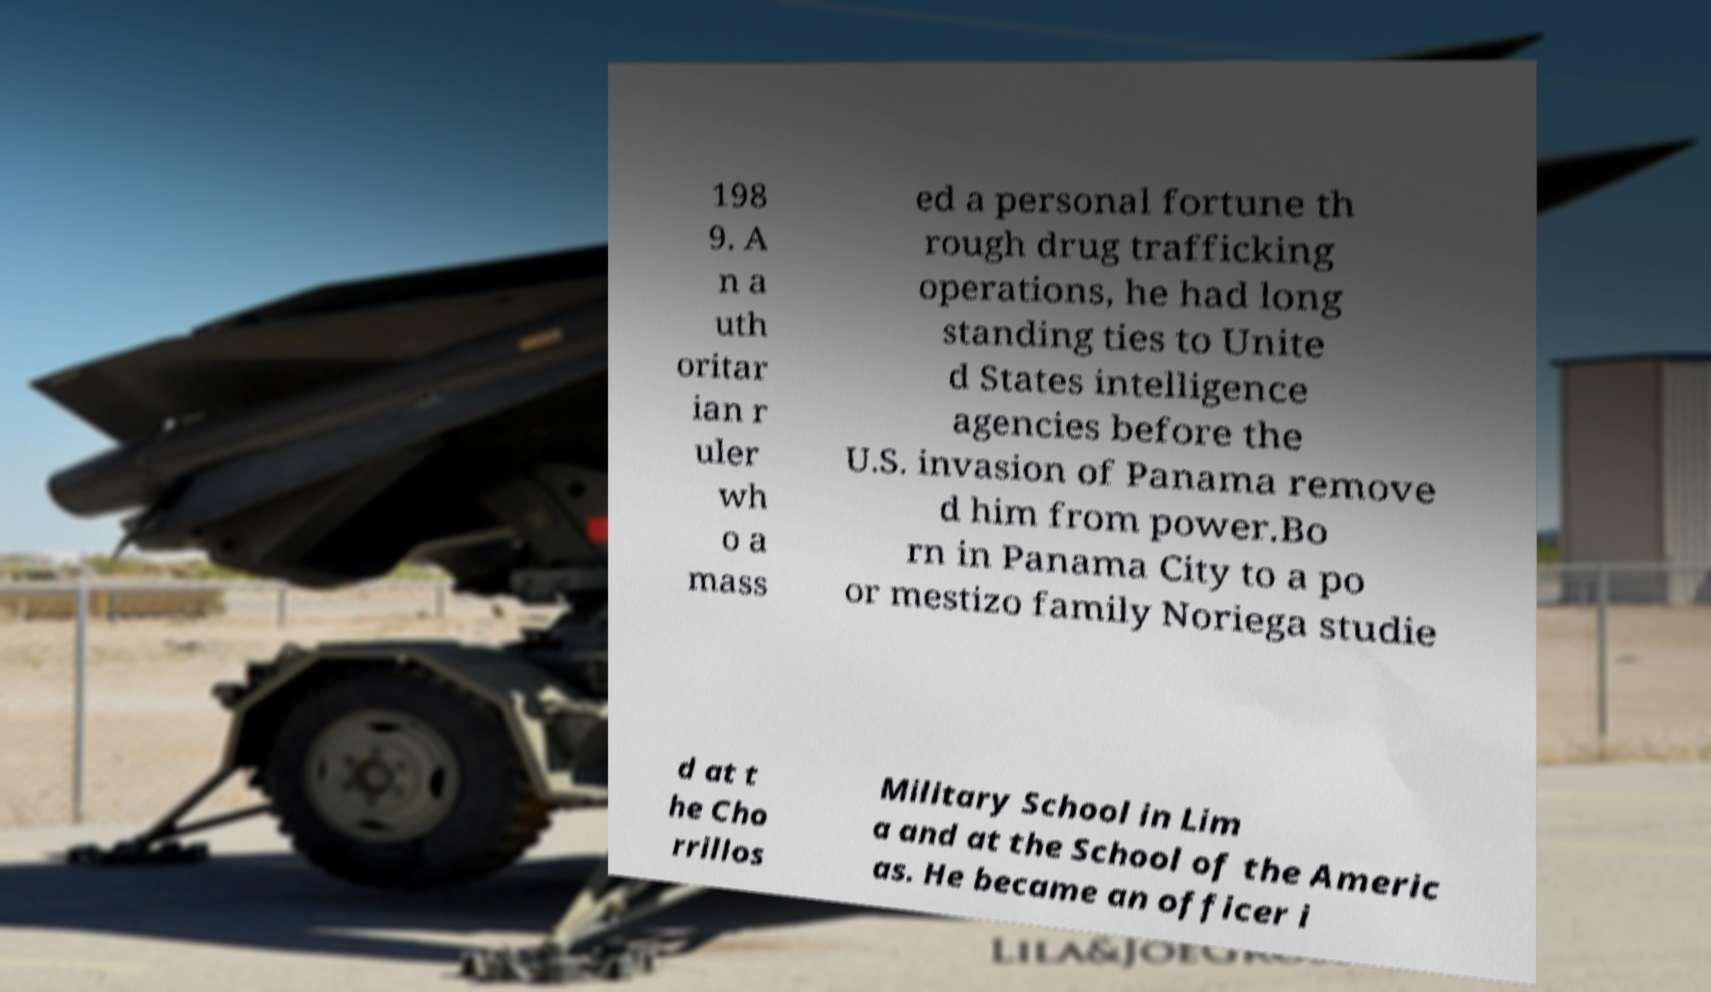There's text embedded in this image that I need extracted. Can you transcribe it verbatim? 198 9. A n a uth oritar ian r uler wh o a mass ed a personal fortune th rough drug trafficking operations, he had long standing ties to Unite d States intelligence agencies before the U.S. invasion of Panama remove d him from power.Bo rn in Panama City to a po or mestizo family Noriega studie d at t he Cho rrillos Military School in Lim a and at the School of the Americ as. He became an officer i 